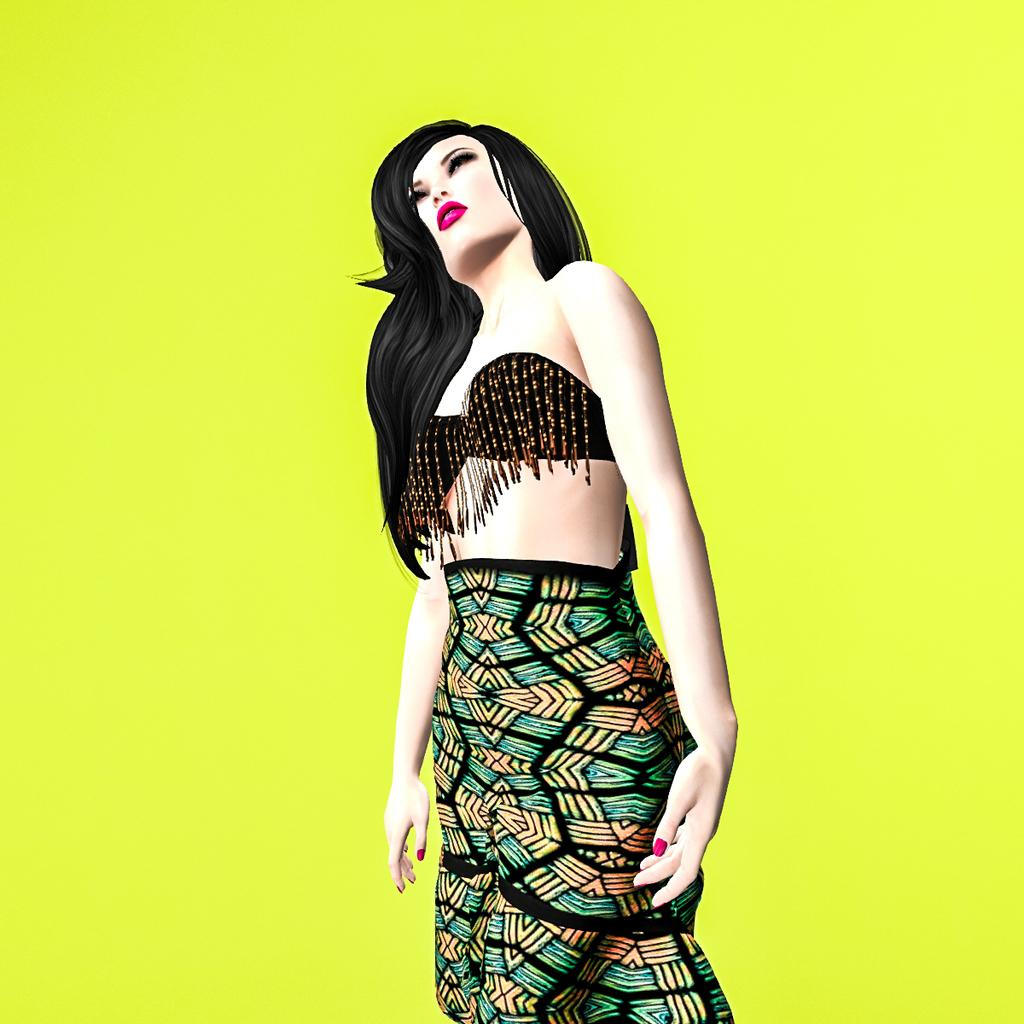What type of image is being described? The image is animated. Can you describe the main subject in the image? There is a woman standing in the image. What color is the background of the image? The background of the image is green in color. How many girls are playing in the cast system in the image? There are no girls or cast system present in the image; it features an animated woman standing in front of a green background. 